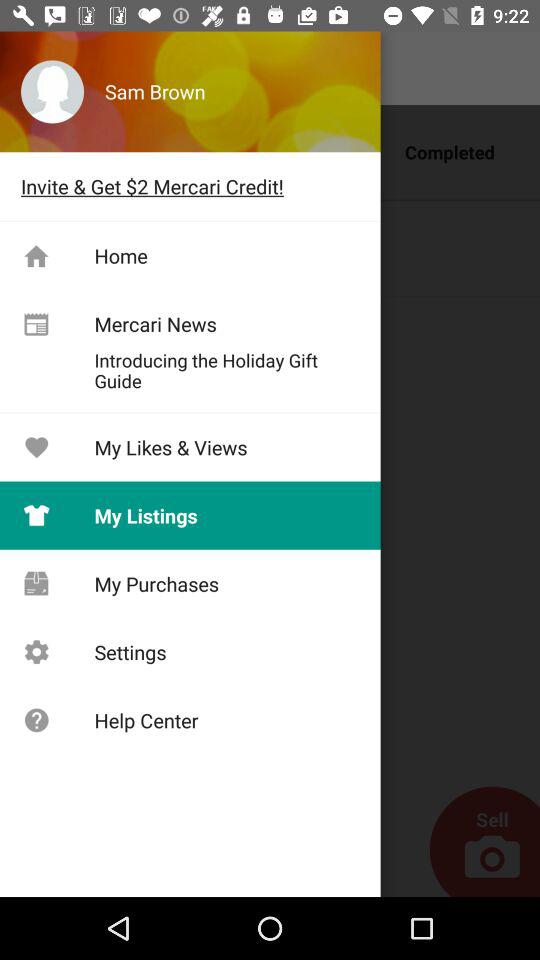What's the user profile name? The user profile name is Sam Brown. 